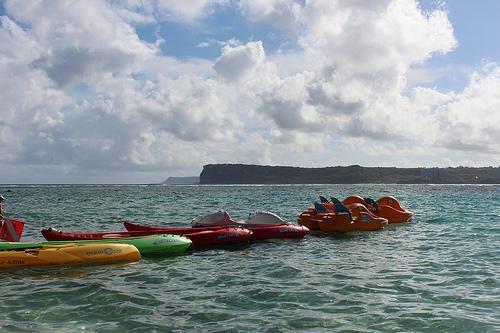How many boats are there?
Give a very brief answer. 7. 